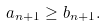<formula> <loc_0><loc_0><loc_500><loc_500>a _ { n + 1 } \geq b _ { n + 1 } .</formula> 